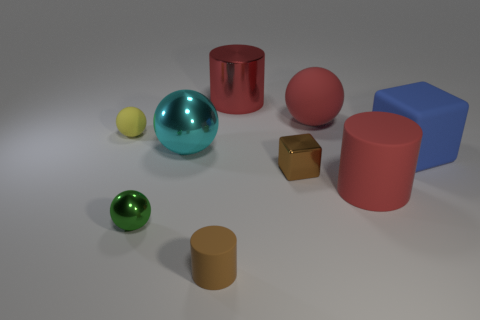Subtract all cyan metallic balls. How many balls are left? 3 Subtract 1 spheres. How many spheres are left? 3 Add 1 tiny brown things. How many objects exist? 10 Subtract all blocks. How many objects are left? 7 Subtract all yellow balls. How many balls are left? 3 Subtract all big red rubber balls. Subtract all rubber blocks. How many objects are left? 7 Add 9 big cyan spheres. How many big cyan spheres are left? 10 Add 1 tiny gray things. How many tiny gray things exist? 1 Subtract 0 green cylinders. How many objects are left? 9 Subtract all green blocks. Subtract all purple cylinders. How many blocks are left? 2 